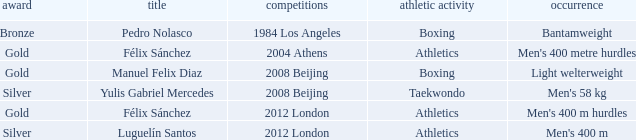What Medal had a Name of manuel felix diaz? Gold. 